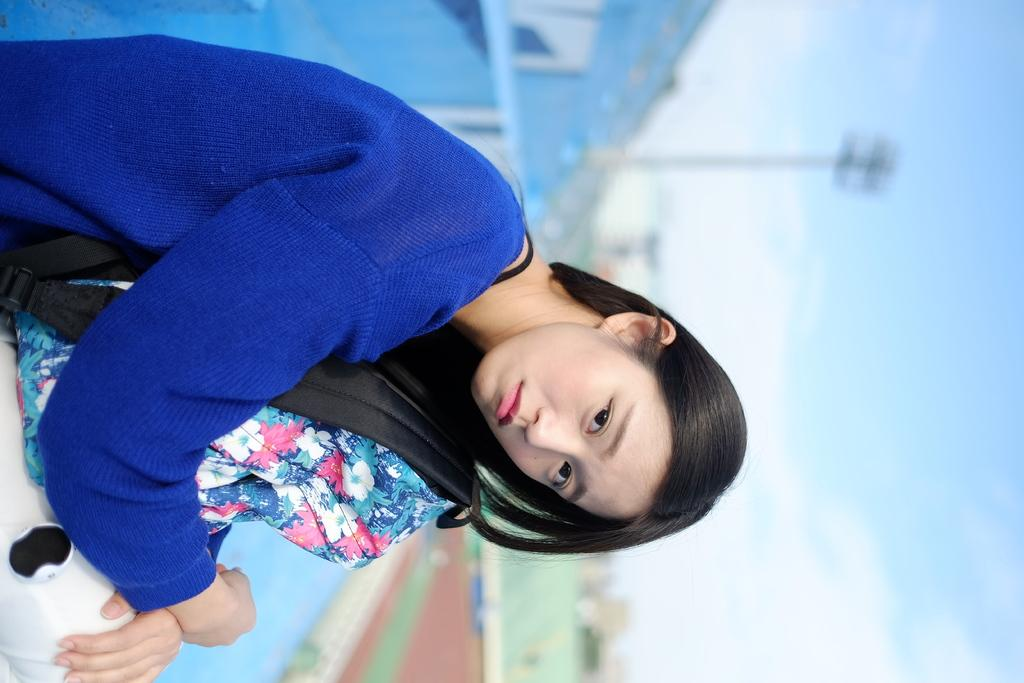Who is the main subject in the image? There is a girl in the image. Where is the girl located in the image? The girl is on the left side of the image. What riddle is the girl trying to solve in the image? There is no riddle present in the image; it simply shows a girl on the left side. 